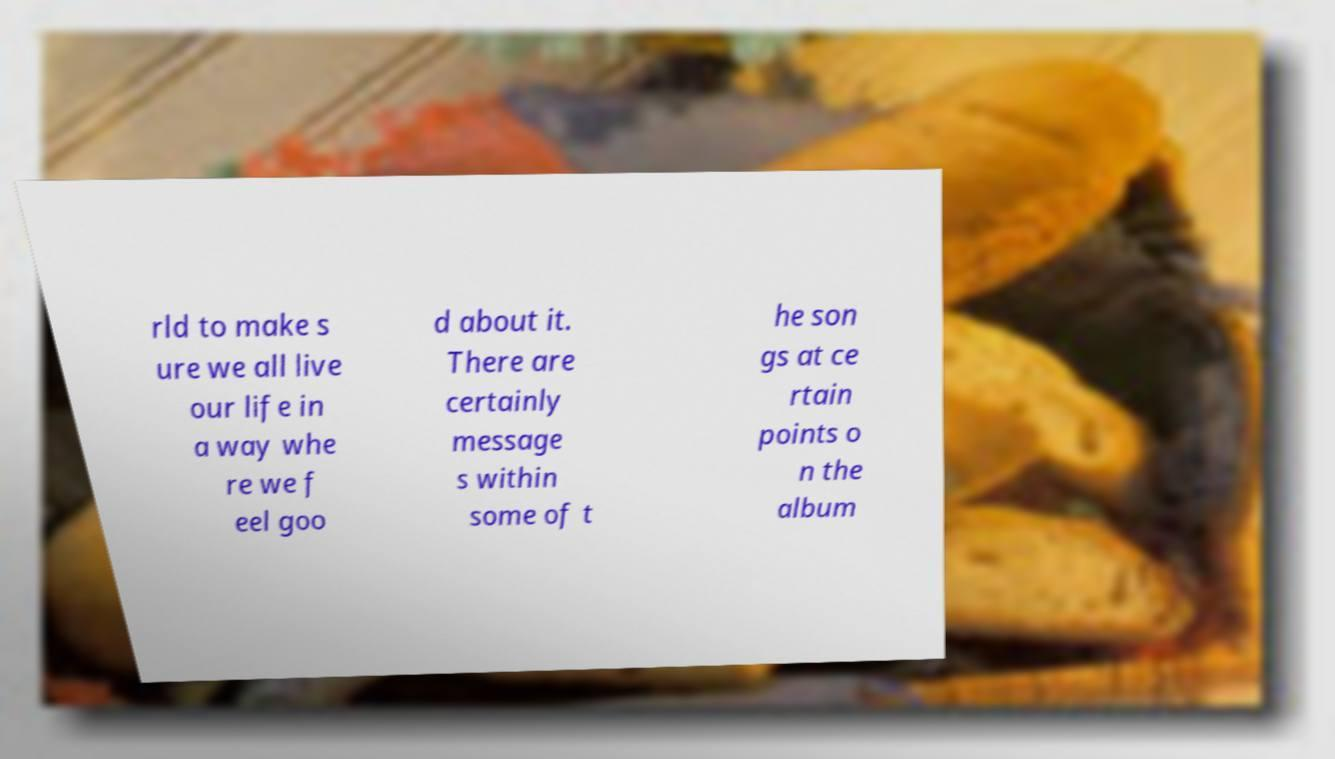There's text embedded in this image that I need extracted. Can you transcribe it verbatim? rld to make s ure we all live our life in a way whe re we f eel goo d about it. There are certainly message s within some of t he son gs at ce rtain points o n the album 